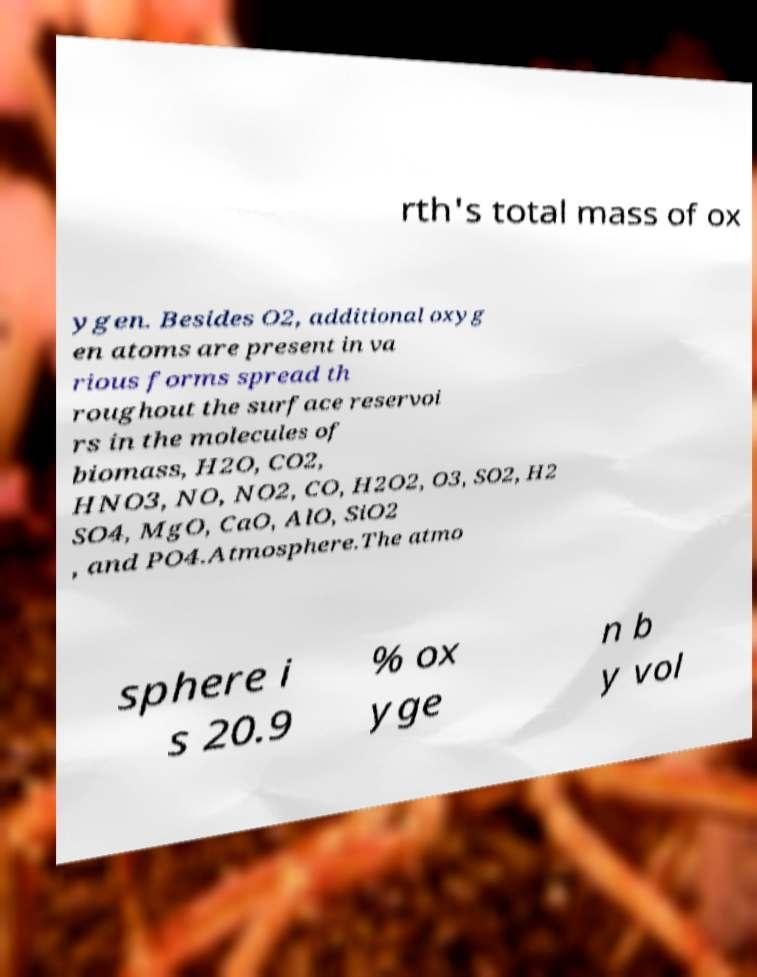Can you accurately transcribe the text from the provided image for me? rth's total mass of ox ygen. Besides O2, additional oxyg en atoms are present in va rious forms spread th roughout the surface reservoi rs in the molecules of biomass, H2O, CO2, HNO3, NO, NO2, CO, H2O2, O3, SO2, H2 SO4, MgO, CaO, AlO, SiO2 , and PO4.Atmosphere.The atmo sphere i s 20.9 % ox yge n b y vol 